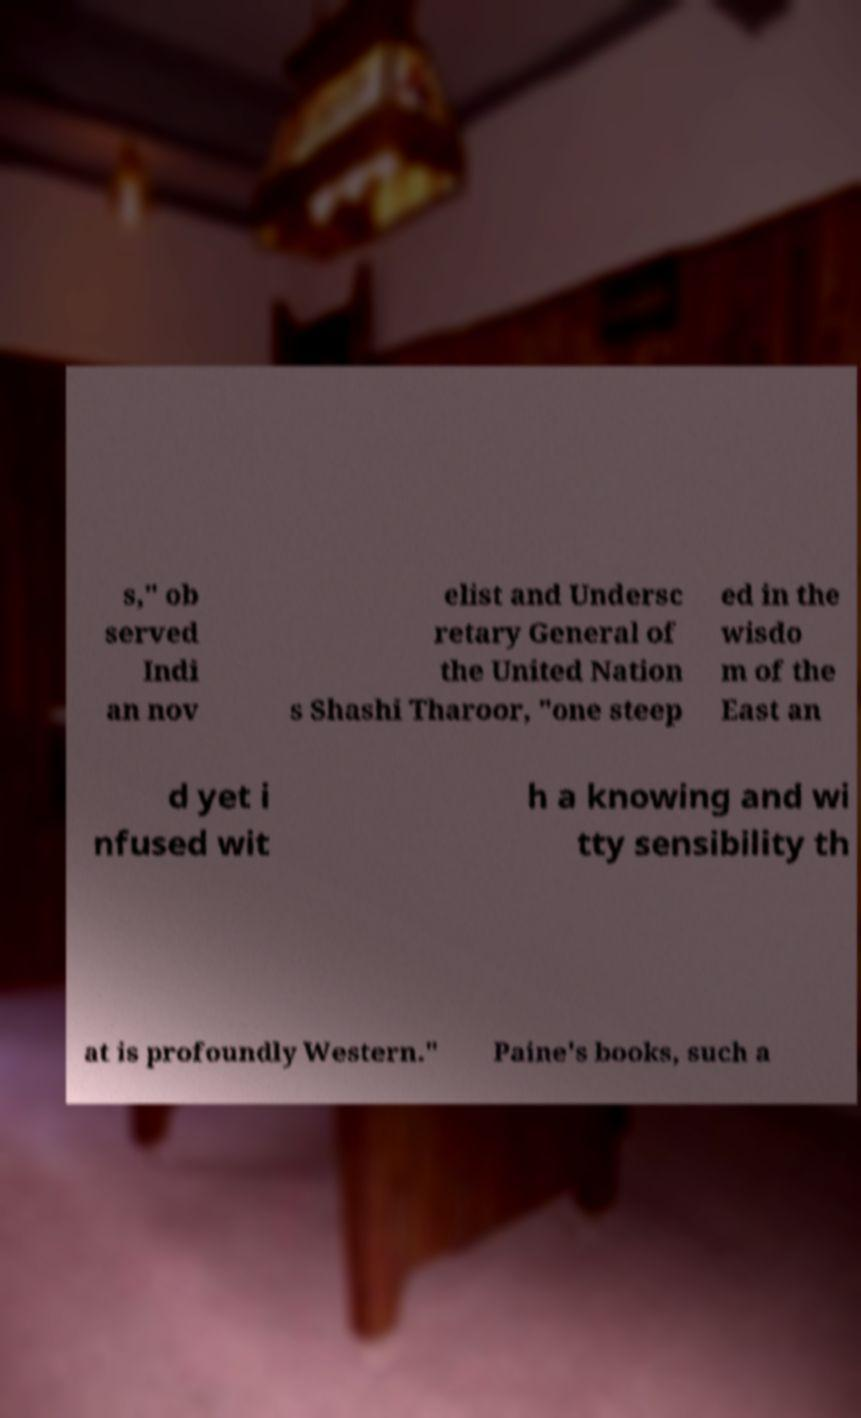Could you extract and type out the text from this image? s," ob served Indi an nov elist and Undersc retary General of the United Nation s Shashi Tharoor, "one steep ed in the wisdo m of the East an d yet i nfused wit h a knowing and wi tty sensibility th at is profoundly Western." Paine's books, such a 